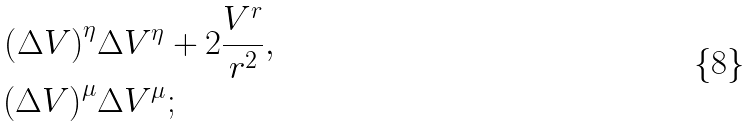<formula> <loc_0><loc_0><loc_500><loc_500>\left ( \Delta V \right ) ^ { \eta } & \Delta V ^ { \eta } + 2 \frac { V ^ { r } } { r ^ { 2 } } , \\ \left ( \Delta V \right ) ^ { \mu } & \Delta V ^ { \mu } ;</formula> 